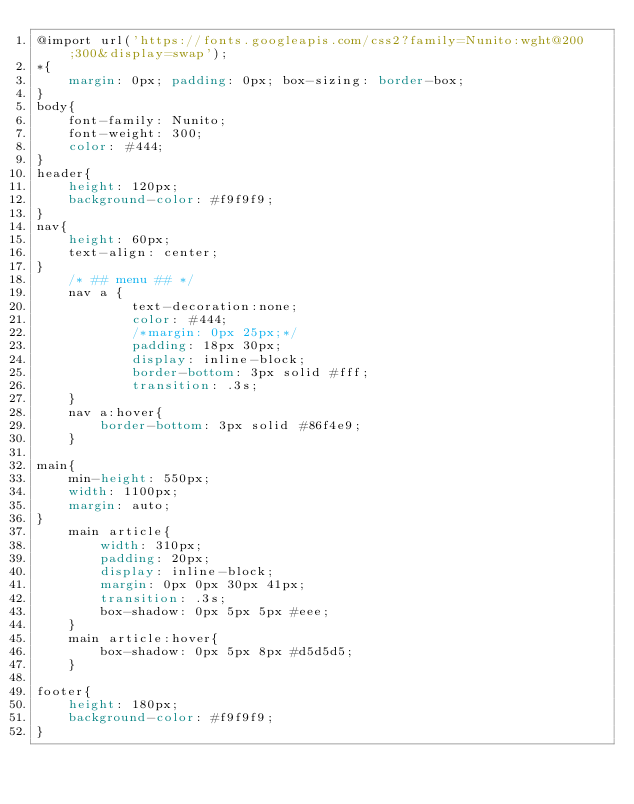<code> <loc_0><loc_0><loc_500><loc_500><_CSS_>@import url('https://fonts.googleapis.com/css2?family=Nunito:wght@200;300&display=swap');
*{
    margin: 0px; padding: 0px; box-sizing: border-box;
}
body{
    font-family: Nunito;
    font-weight: 300;
    color: #444;
}
header{
    height: 120px;
    background-color: #f9f9f9;
}
nav{
    height: 60px;
    text-align: center;
}
    /* ## menu ## */
    nav a {
            text-decoration:none;
            color: #444;
            /*margin: 0px 25px;*/
            padding: 18px 30px;
            display: inline-block;
            border-bottom: 3px solid #fff;
            transition: .3s;
    }
    nav a:hover{
        border-bottom: 3px solid #86f4e9;
    }

main{
    min-height: 550px;
    width: 1100px;
    margin: auto;
}
    main article{
        width: 310px;
        padding: 20px;
        display: inline-block;
        margin: 0px 0px 30px 41px;
        transition: .3s;
        box-shadow: 0px 5px 5px #eee;
    }
    main article:hover{
        box-shadow: 0px 5px 8px #d5d5d5;
    }

footer{
    height: 180px;
    background-color: #f9f9f9;
}</code> 